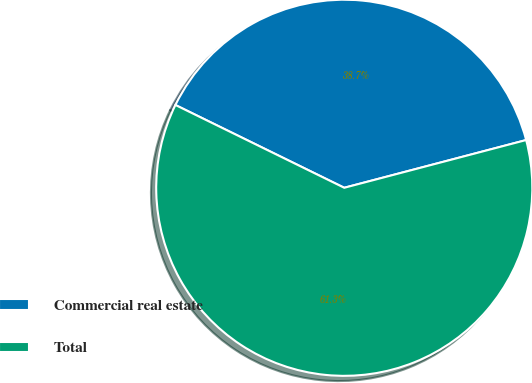Convert chart to OTSL. <chart><loc_0><loc_0><loc_500><loc_500><pie_chart><fcel>Commercial real estate<fcel>Total<nl><fcel>38.66%<fcel>61.34%<nl></chart> 